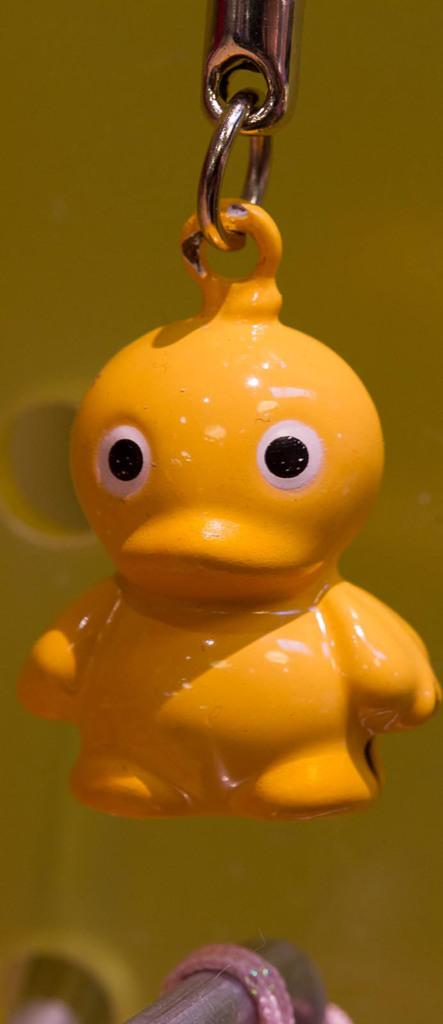What is the main object in the foreground of the image? There is a toy key chain-like object in the foreground of the image. What color is the background of the image? The background of the image is yellow. Who is the owner of the flame in the image? There is no flame present in the image, so it is not possible to determine an owner. 